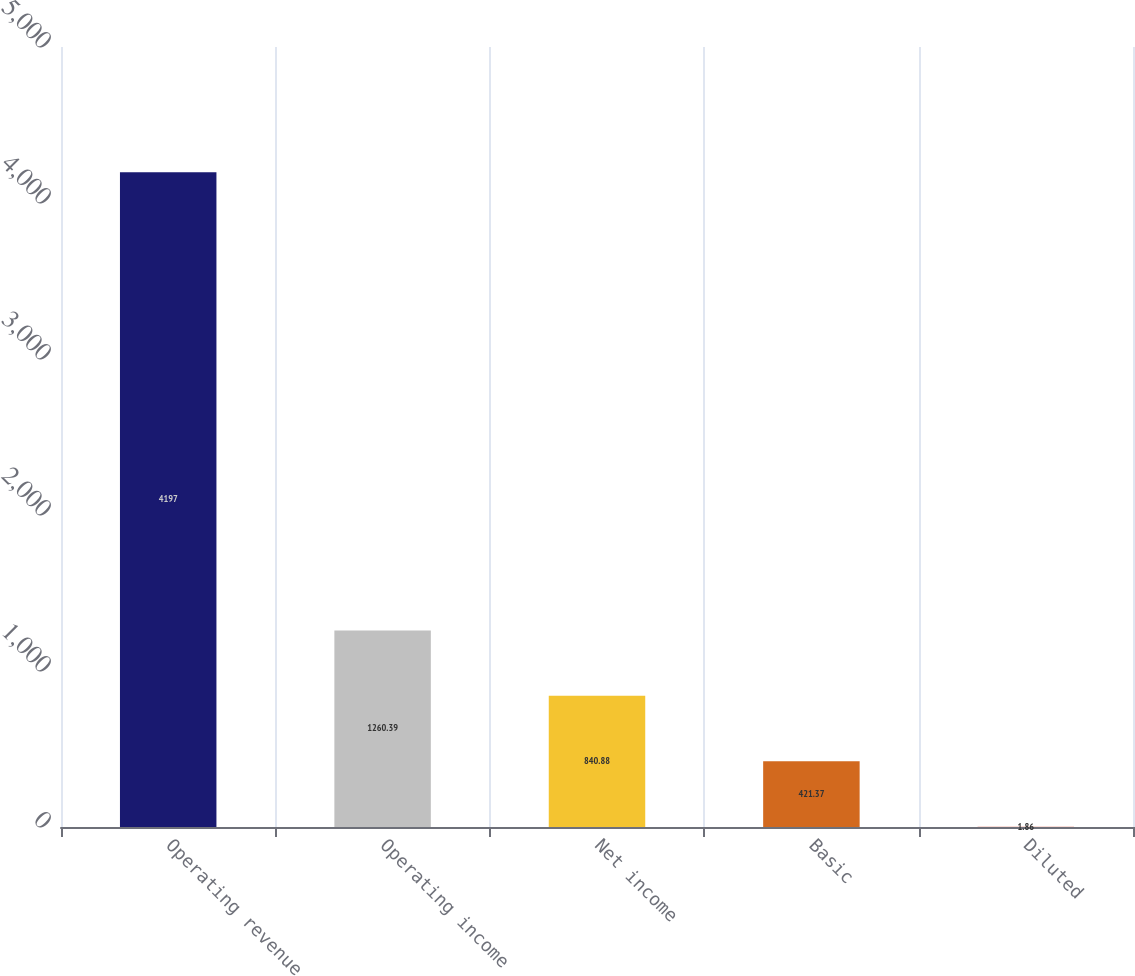<chart> <loc_0><loc_0><loc_500><loc_500><bar_chart><fcel>Operating revenue<fcel>Operating income<fcel>Net income<fcel>Basic<fcel>Diluted<nl><fcel>4197<fcel>1260.39<fcel>840.88<fcel>421.37<fcel>1.86<nl></chart> 